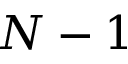<formula> <loc_0><loc_0><loc_500><loc_500>N - 1</formula> 